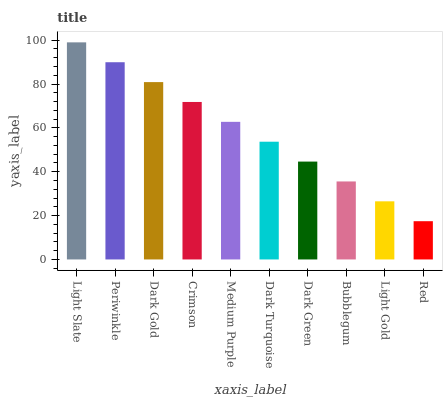Is Light Slate the maximum?
Answer yes or no. Yes. Is Periwinkle the minimum?
Answer yes or no. No. Is Periwinkle the maximum?
Answer yes or no. No. Is Light Slate greater than Periwinkle?
Answer yes or no. Yes. Is Periwinkle less than Light Slate?
Answer yes or no. Yes. Is Periwinkle greater than Light Slate?
Answer yes or no. No. Is Light Slate less than Periwinkle?
Answer yes or no. No. Is Medium Purple the high median?
Answer yes or no. Yes. Is Dark Turquoise the low median?
Answer yes or no. Yes. Is Periwinkle the high median?
Answer yes or no. No. Is Dark Green the low median?
Answer yes or no. No. 